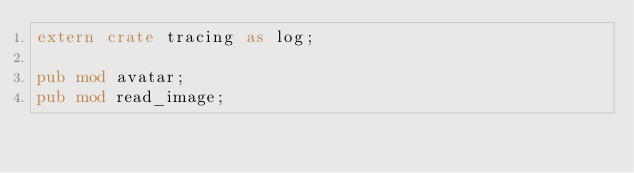Convert code to text. <code><loc_0><loc_0><loc_500><loc_500><_Rust_>extern crate tracing as log;

pub mod avatar;
pub mod read_image;
</code> 